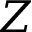<formula> <loc_0><loc_0><loc_500><loc_500>Z</formula> 